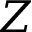<formula> <loc_0><loc_0><loc_500><loc_500>Z</formula> 